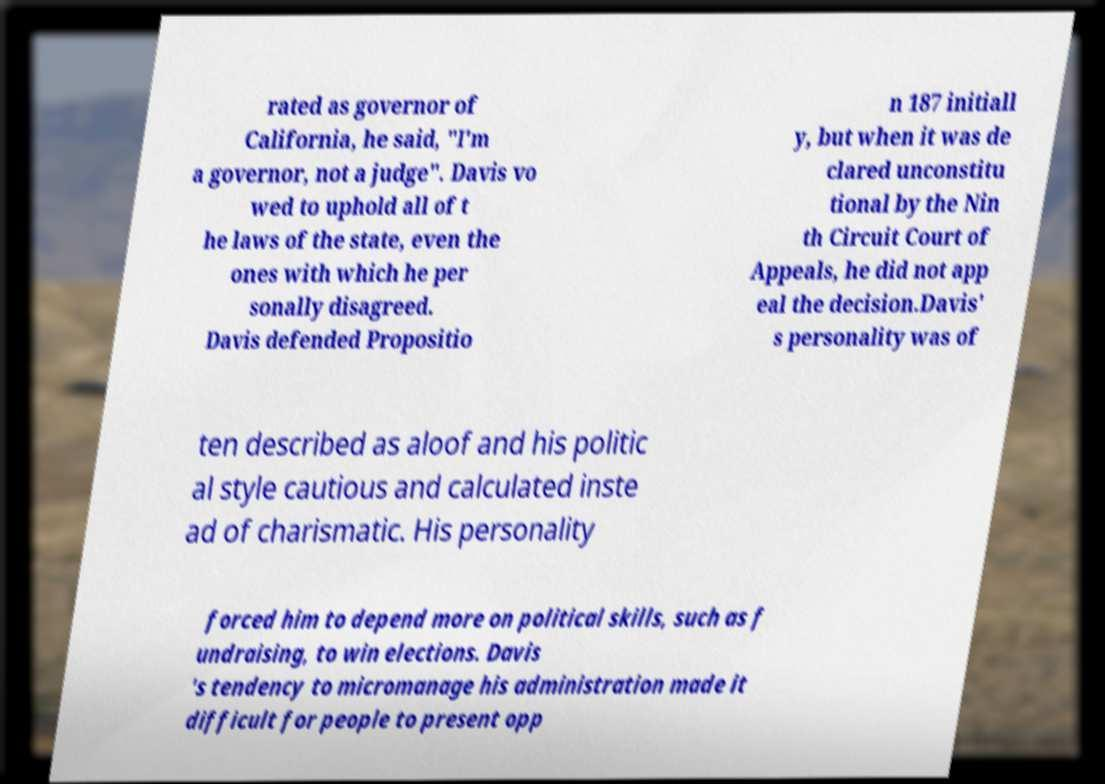What messages or text are displayed in this image? I need them in a readable, typed format. rated as governor of California, he said, "I'm a governor, not a judge". Davis vo wed to uphold all of t he laws of the state, even the ones with which he per sonally disagreed. Davis defended Propositio n 187 initiall y, but when it was de clared unconstitu tional by the Nin th Circuit Court of Appeals, he did not app eal the decision.Davis' s personality was of ten described as aloof and his politic al style cautious and calculated inste ad of charismatic. His personality forced him to depend more on political skills, such as f undraising, to win elections. Davis 's tendency to micromanage his administration made it difficult for people to present opp 